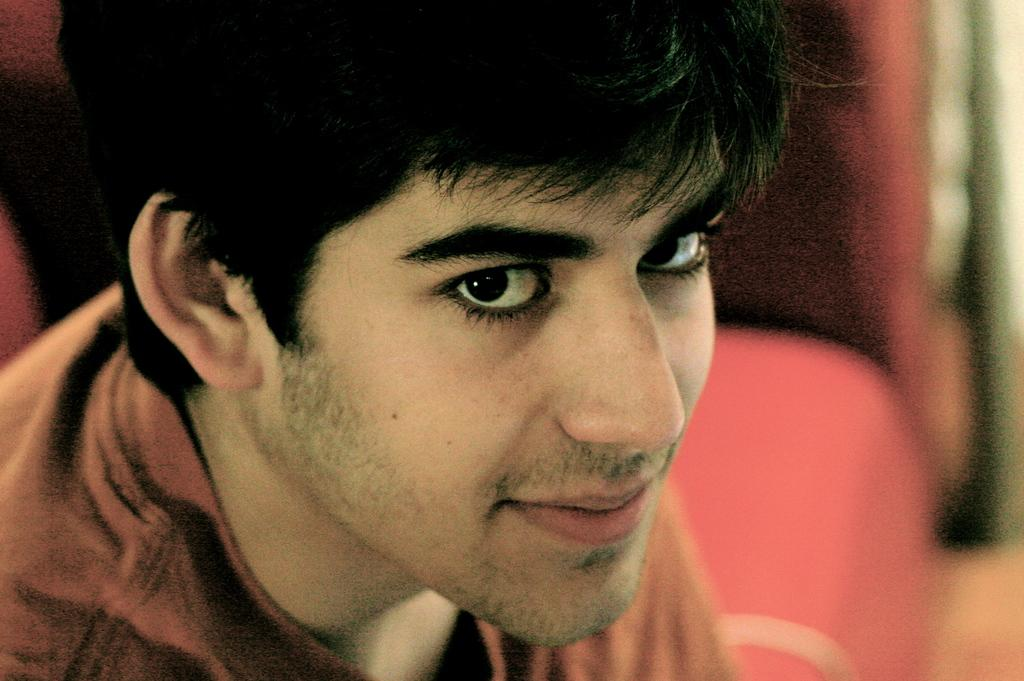What is present in the image? There is a man in the image. Can you describe the background of the image? The background of the image is blurred. What type of pail is the man using to trip over in the image? There is no pail or any indication of tripping present in the image. How many hands does the man have in the image? The image does not provide enough detail to determine the number of hands the man has. 